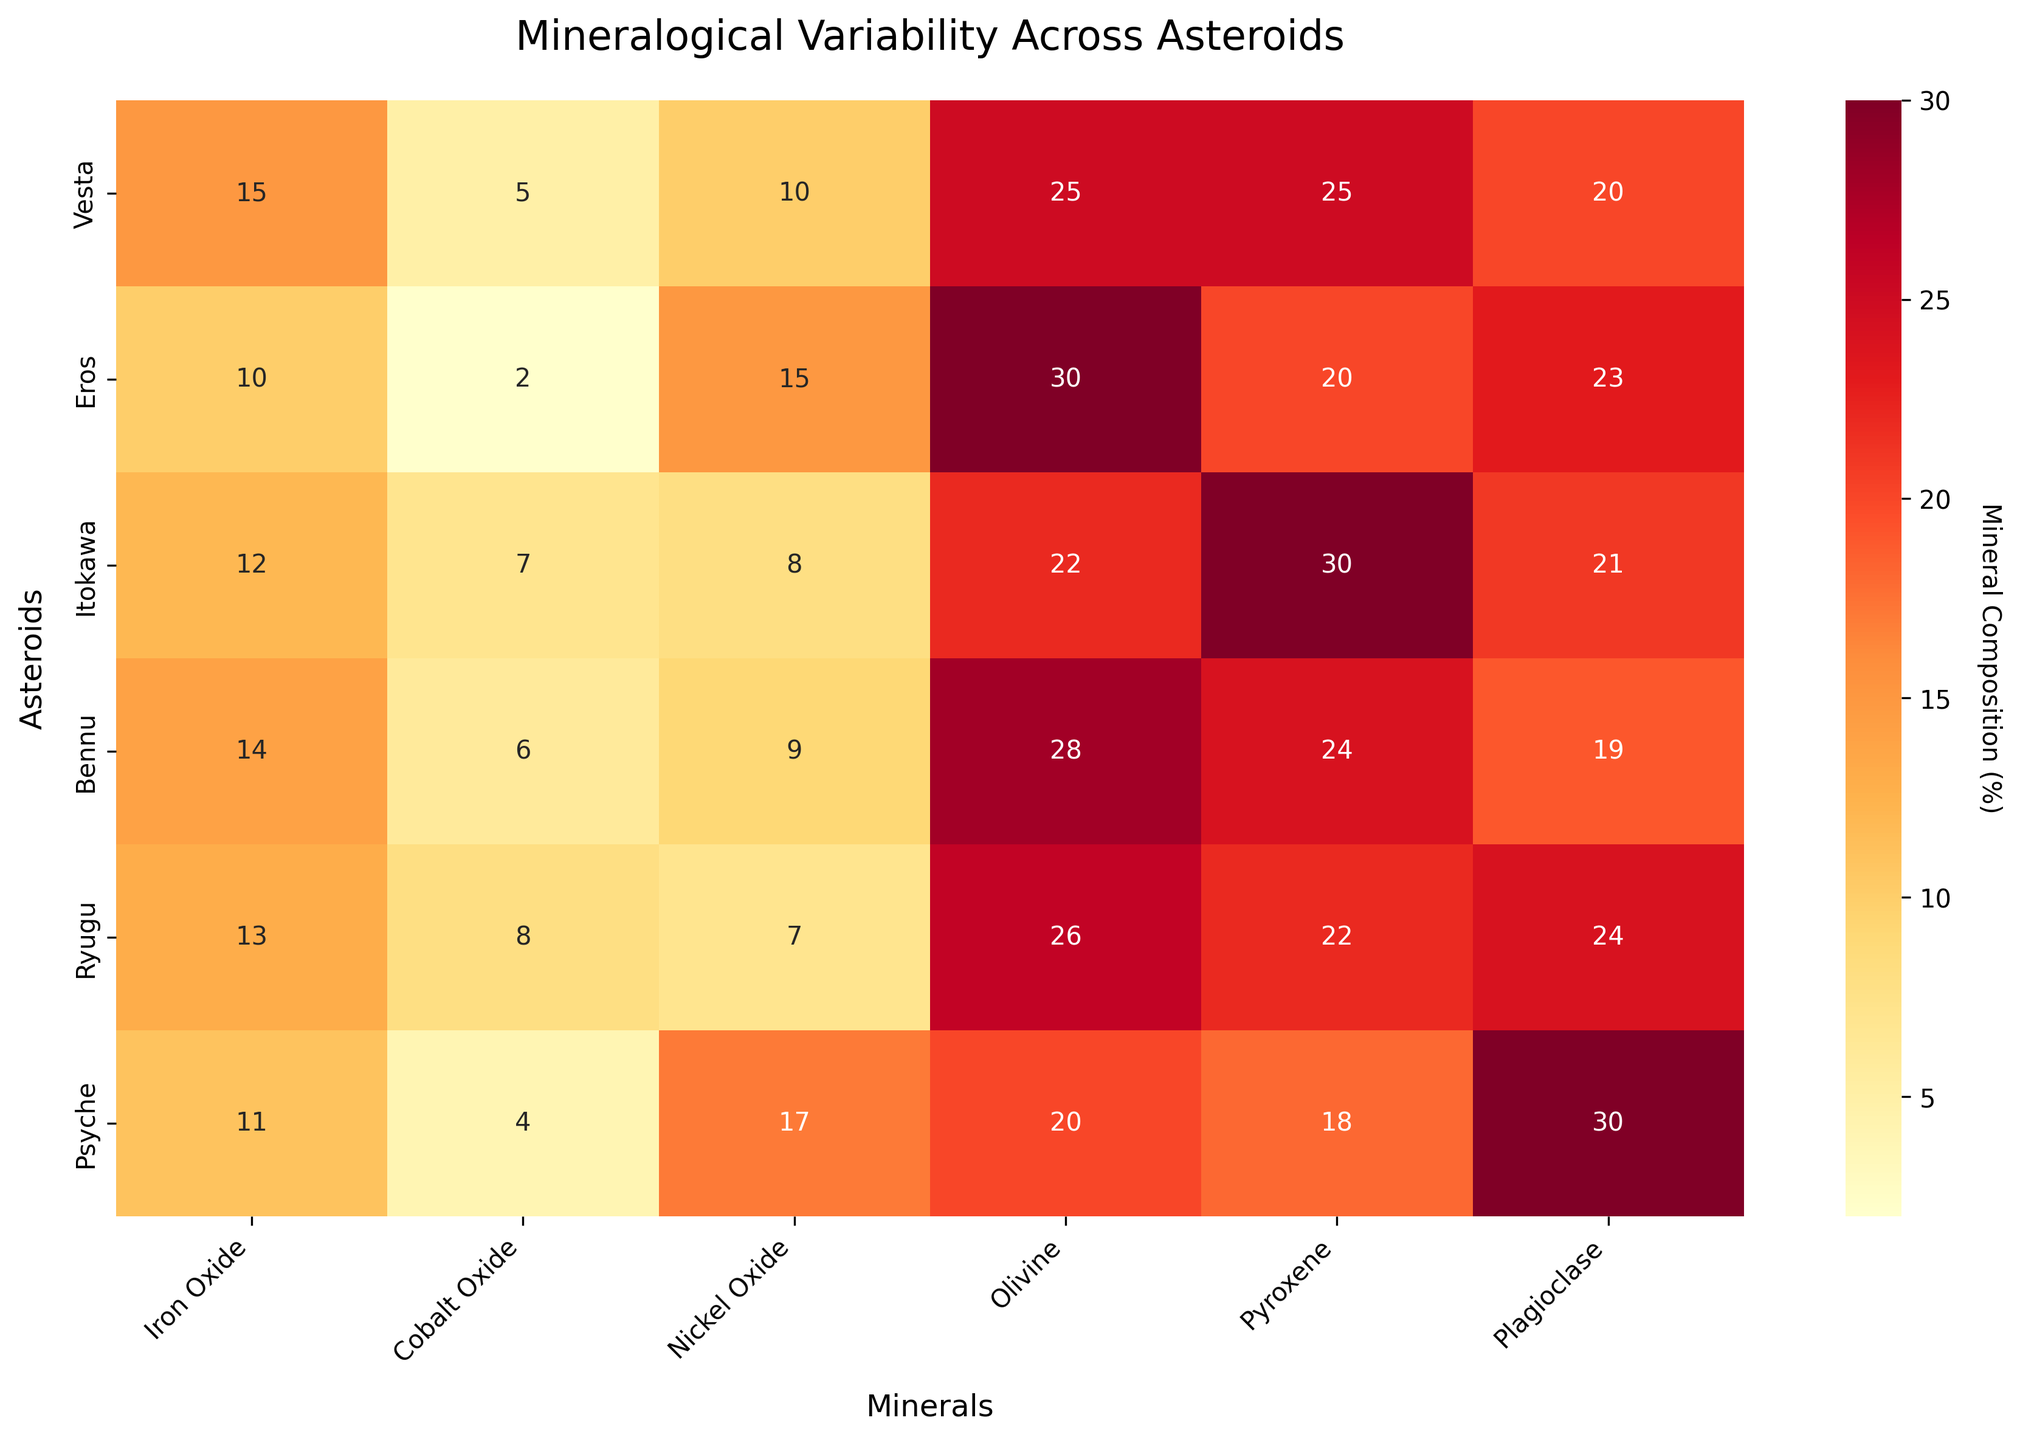Where is the highest concentration of Nickel Oxide found among the asteroids? Look at the column labeled 'Nickel Oxide' and identify the row with the highest value. 'Psyche' has 17% Nickel Oxide, which is the highest.
Answer: Psyche Which mineral has the highest average composition across all listed asteroids? Calculate the average composition for each mineral column. Sum up the values for each mineral and divide by the number of asteroids (6). The averages are: Iron Oxide (12.5), Cobalt Oxide (5.333), Nickel Oxide (11), Olivine (25.166), Pyroxene (23.166), Plagioclase (22.833). The highest average is Olivine with 25.166%.
Answer: Olivine How does Eros compare to Vesta in terms of Olivine composition? Check the values in the 'Olivine' column for both Eros and Vesta. Eros has 30% Olivine while Vesta has 25% Olivine. Eros has 5% more Olivine compared to Vesta.
Answer: Eros has more Olivine Which asteroid shows the lowest concentration of Cobalt Oxide? Look at the column labeled 'Cobalt Oxide' and identify the row with the smallest value. Eros has the lowest concentration with 2%.
Answer: Eros What is the combined percentage of Iron Oxide and Pyroxene in Bennu? Add the values for Iron Oxide and Pyroxene in the row for Bennu. Iron Oxide is 14% and Pyroxene is 24%. So, 14 + 24 = 38%.
Answer: 38% Which two minerals are most abundant in Ryugu? Look at the row for Ryugu and identify the two highest values. Olivine has 26% and Plagioclase has 24%.
Answer: Olivine and Plagioclase Which asteroid has the most balanced distribution of Iron Oxide and Nickel Oxide? Check the differences between the values of Iron Oxide and Nickel Oxide for each asteroid. The smallest difference is for Bennu (14% Iron Oxide and 9% Nickel Oxide, difference of 5%).
Answer: Bennu If you sum the concentrations of plagioclase for all asteroids, what is the result? Add up the values in the 'Plagioclase' column. The sum is 20 + 23 + 21 + 19 + 24 + 30 = 137%.
Answer: 137% How does the Pyroxene concentration in Itokawa compare to that in Psyche? Check the values in the 'Pyroxene' column for both Itokawa and Psyche. Itokawa has 30% Pyroxene, while Psyche has 18%. Itokawa has 12% more Pyroxene.
Answer: Itokawa has more Pyroxene Which asteroid has the highest total mineral composition? Sum up the values across all minerals for each asteroid. The total for each asteroid is: Vesta (100), Eros (100), Itokawa (100), Bennu (100), Ryugu (100), Psyche (100). All asteroids have equal total mineral compositions of 100%.
Answer: All have equal total 